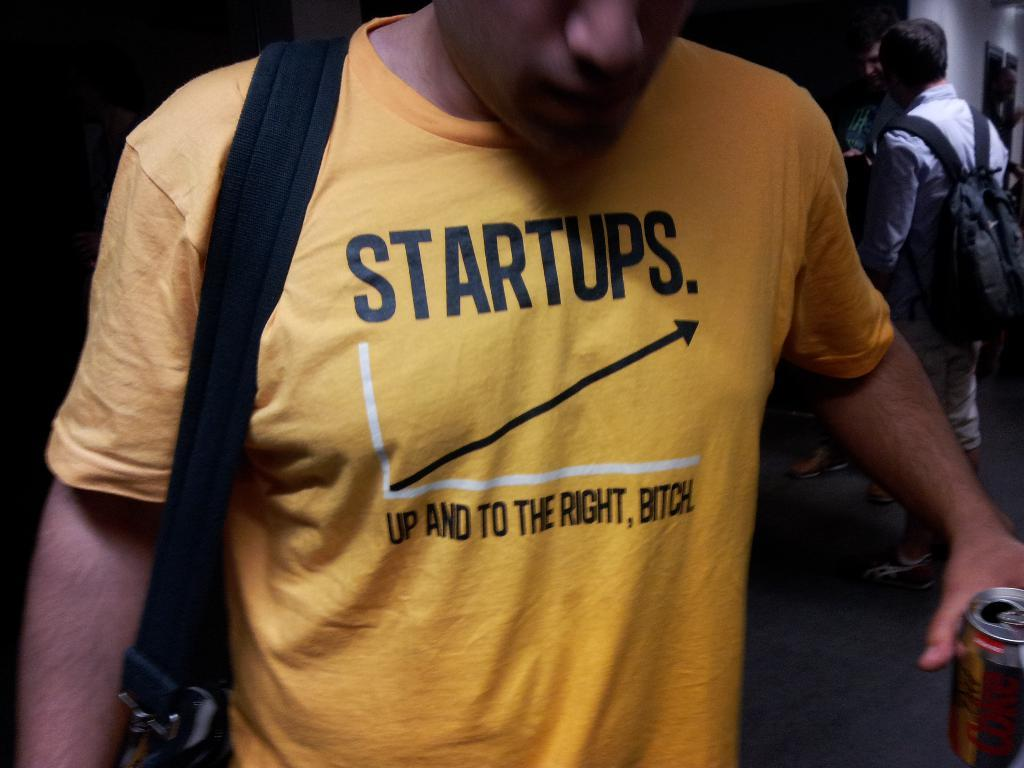<image>
Share a concise interpretation of the image provided. A man is wearing a yellow shirt with the word startups on it. 